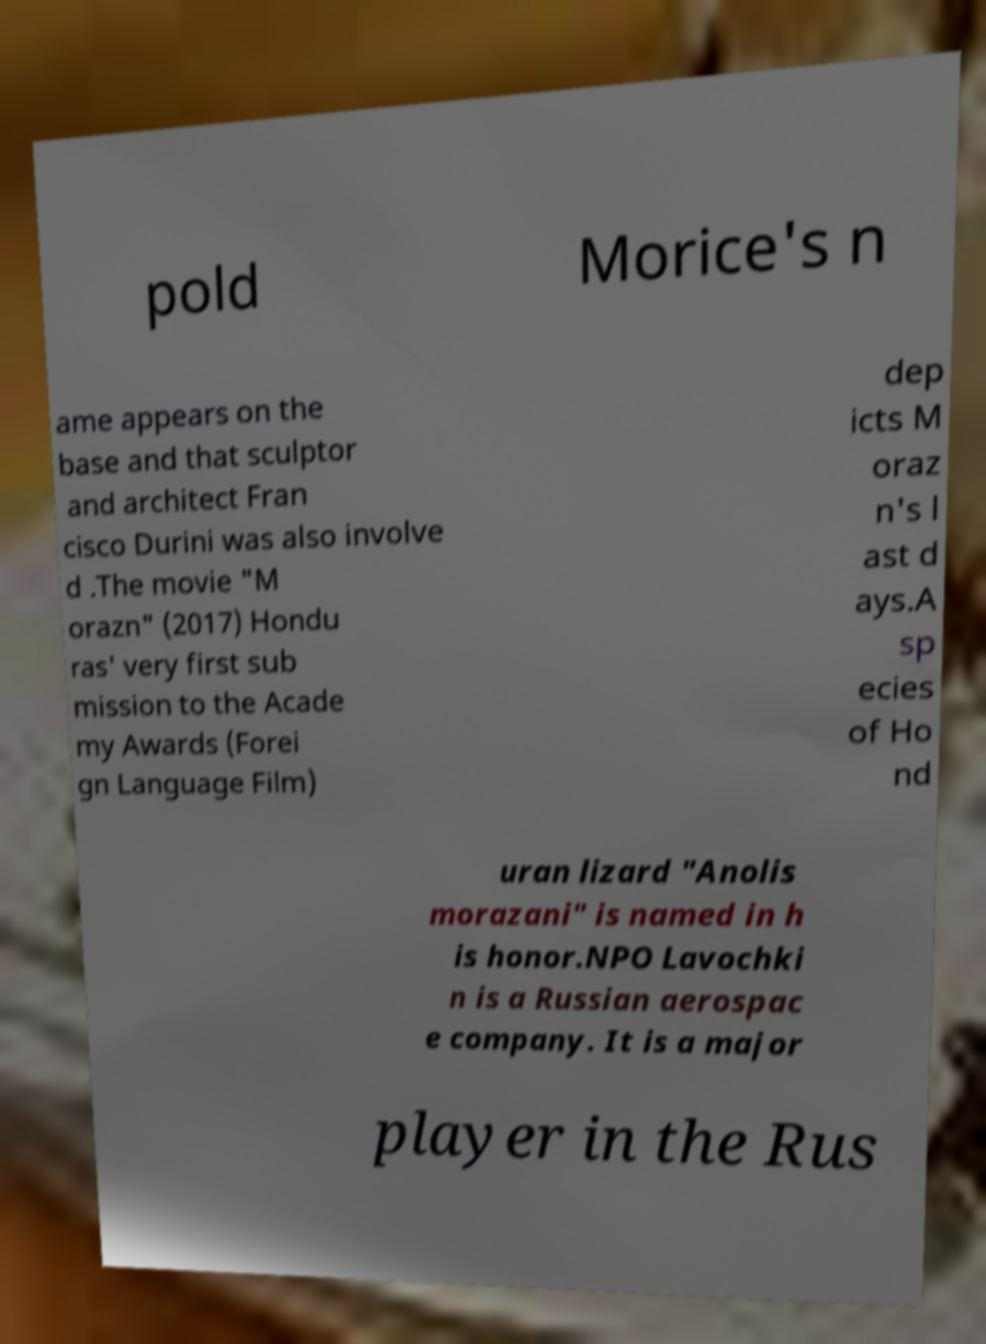Can you accurately transcribe the text from the provided image for me? pold Morice's n ame appears on the base and that sculptor and architect Fran cisco Durini was also involve d .The movie "M orazn" (2017) Hondu ras' very first sub mission to the Acade my Awards (Forei gn Language Film) dep icts M oraz n's l ast d ays.A sp ecies of Ho nd uran lizard "Anolis morazani" is named in h is honor.NPO Lavochki n is a Russian aerospac e company. It is a major player in the Rus 